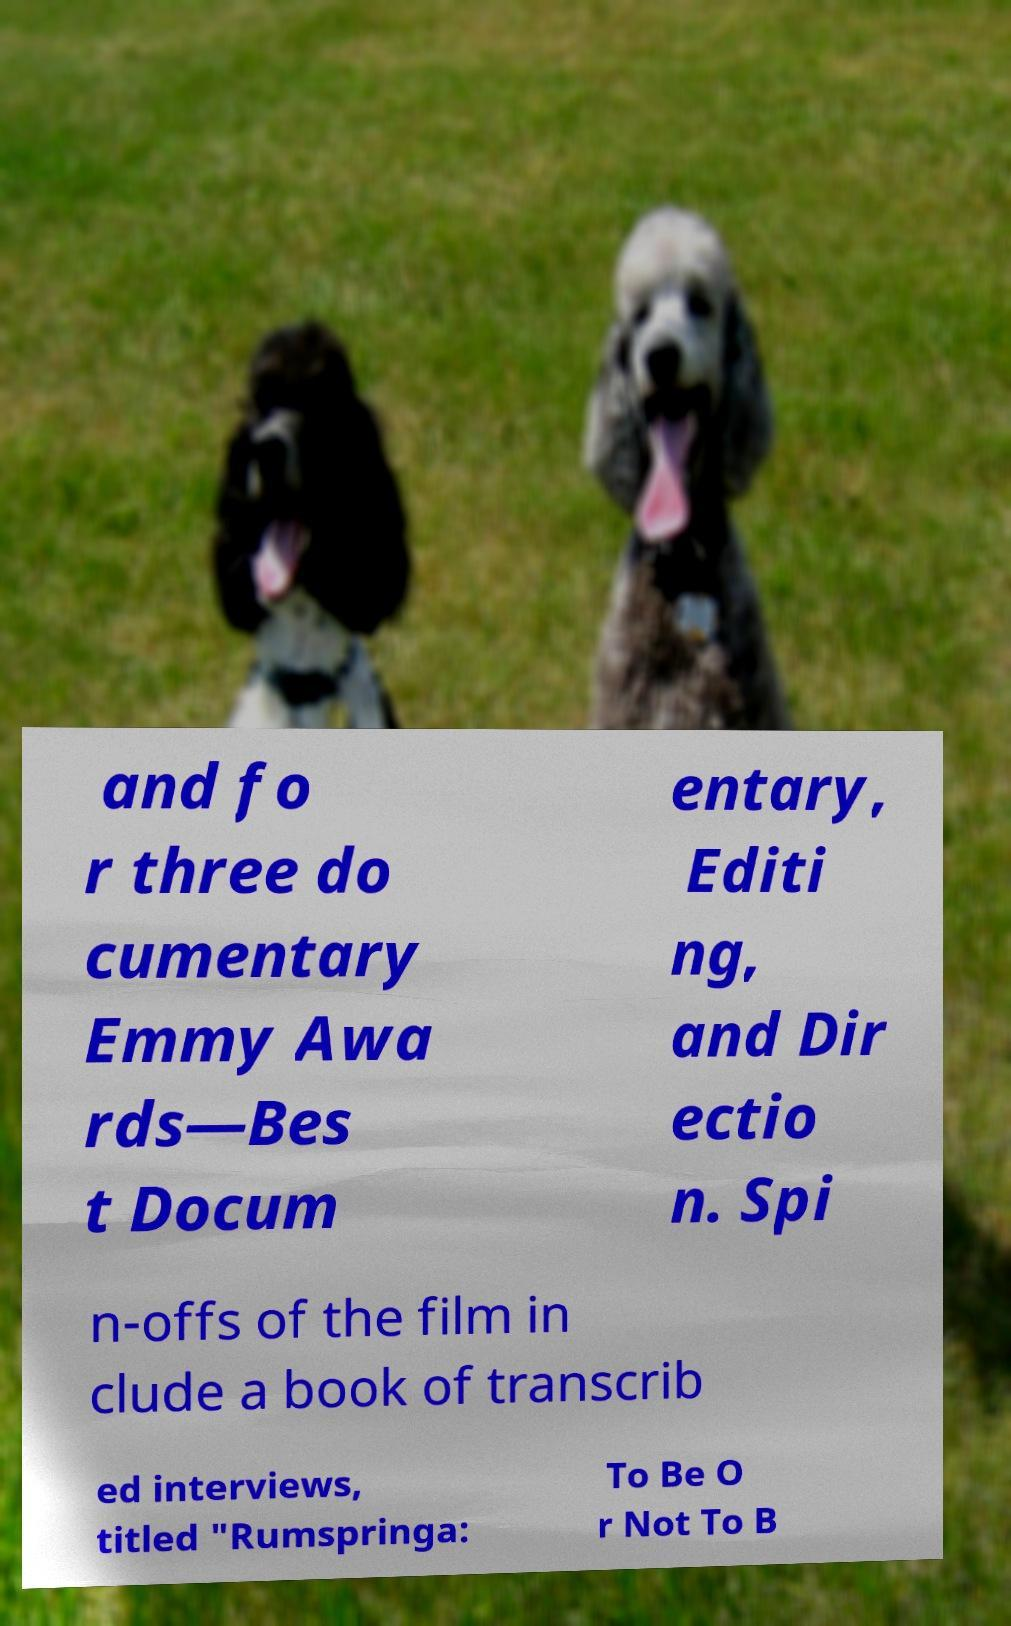There's text embedded in this image that I need extracted. Can you transcribe it verbatim? and fo r three do cumentary Emmy Awa rds—Bes t Docum entary, Editi ng, and Dir ectio n. Spi n-offs of the film in clude a book of transcrib ed interviews, titled "Rumspringa: To Be O r Not To B 